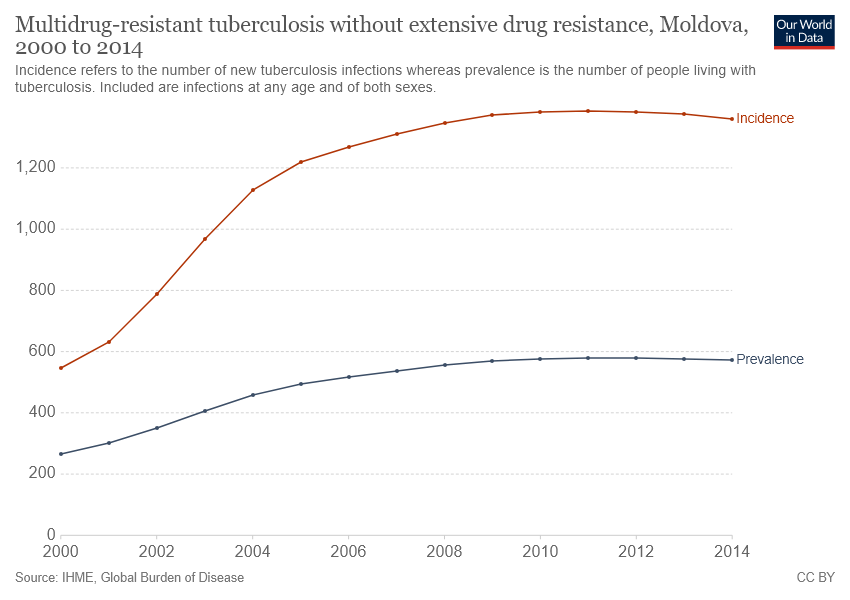Outline some significant characteristics in this image. A red line chart is a type of chart that displays data over time and uses a red line to represent that data. The chart is often used to visualize trends and changes in data over time. The term "red line chart" is often used as a shorthand way of referring to this type of chart. The term "incidence" is not commonly used in the context of red line charts. The incidence in 2004 reached a threshold of 1000, as indicated in the chart. 